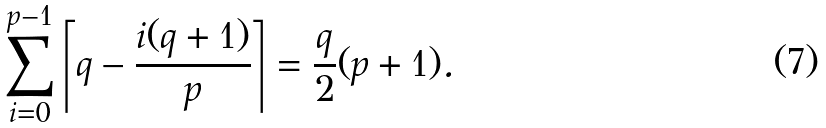Convert formula to latex. <formula><loc_0><loc_0><loc_500><loc_500>\sum _ { i = 0 } ^ { p - 1 } \left \lceil q - \frac { i ( q + 1 ) } { p } \right \rceil = \frac { q } { 2 } ( p + 1 ) .</formula> 